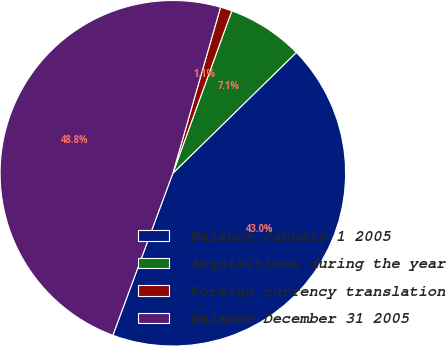<chart> <loc_0><loc_0><loc_500><loc_500><pie_chart><fcel>Balance January 1 2005<fcel>Acquisitions during the year<fcel>Foreign currency translation<fcel>Balance December 31 2005<nl><fcel>42.97%<fcel>7.13%<fcel>1.09%<fcel>48.81%<nl></chart> 